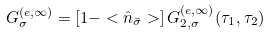Convert formula to latex. <formula><loc_0><loc_0><loc_500><loc_500>G _ { \sigma } ^ { ( e , \infty ) } = \left [ 1 - < \hat { n } _ { \bar { \sigma } } > \right ] G _ { 2 , \sigma } ^ { ( e , \infty ) } ( \tau _ { 1 } , \tau _ { 2 } )</formula> 